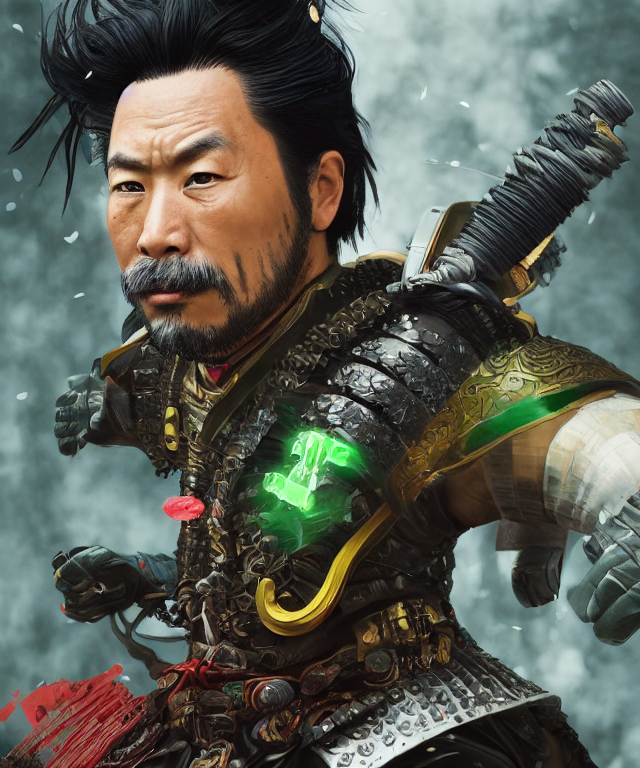Are the colors in the image dull? The colors in the image are quite vibrant and dynamic. The character is depicted with a rich armor palette, incorporating deep blacks, metallic grays, and gold accents, alongside a glowing green element at the waist. The background's cool tones and the subtle red splashes add contrast, making the overall color scheme lively and far from dull. 